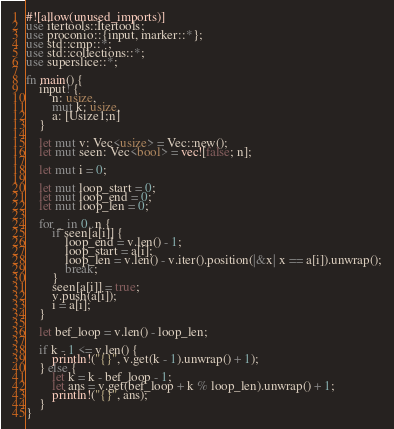<code> <loc_0><loc_0><loc_500><loc_500><_Rust_>#![allow(unused_imports)]
use itertools::Itertools;
use proconio::{input, marker::*};
use std::cmp::*;
use std::collections::*;
use superslice::*;

fn main() {
    input! {
        n: usize,
        mut k: usize,
        a: [Usize1;n]
    }

    let mut v: Vec<usize> = Vec::new();
    let mut seen: Vec<bool> = vec![false; n];

    let mut i = 0;

    let mut loop_start = 0;
    let mut loop_end = 0;
    let mut loop_len = 0;

    for _ in 0..n {
        if seen[a[i]] {
            loop_end = v.len() - 1;
            loop_start = a[i];
            loop_len = v.len() - v.iter().position(|&x| x == a[i]).unwrap();
            break;
        }
        seen[a[i]] = true;
        v.push(a[i]);
        i = a[i];
    }

    let bef_loop = v.len() - loop_len;

    if k - 1 <= v.len() {
        println!("{}", v.get(k - 1).unwrap() + 1);
    } else {
        let k = k - bef_loop - 1;
        let ans = v.get(bef_loop + k % loop_len).unwrap() + 1;
        println!("{}", ans);
    }
}
</code> 